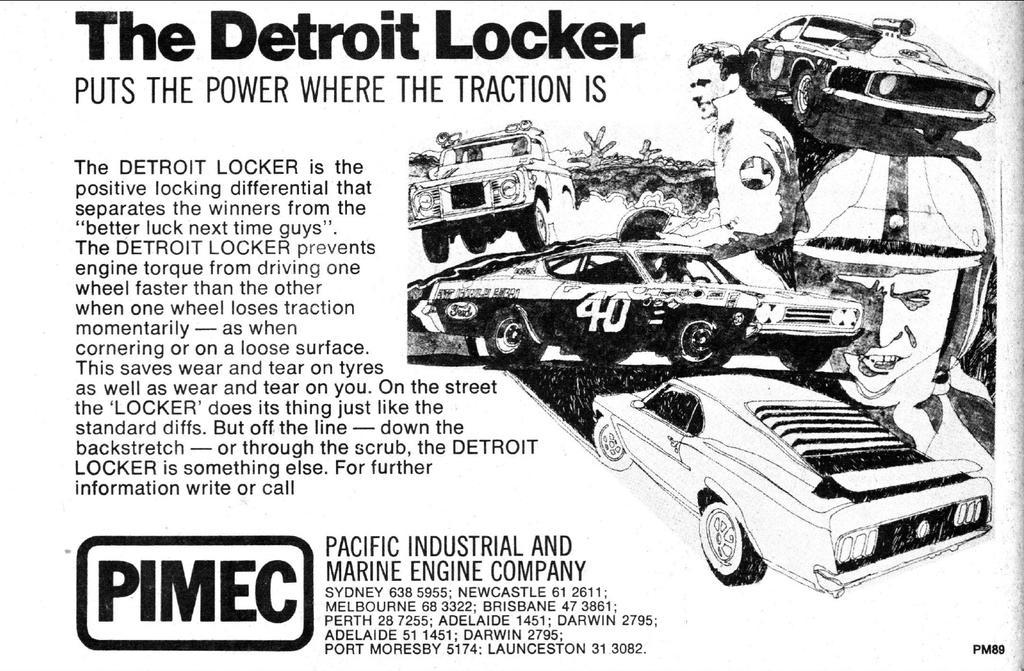In one or two sentences, can you explain what this image depicts? In the image there is black and white picture of two men and cars on the right side with text on the left side. 